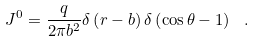Convert formula to latex. <formula><loc_0><loc_0><loc_500><loc_500>J ^ { 0 } = { \frac { q } { 2 \pi { b } ^ { 2 } } } \delta \left ( r - b \right ) \delta \left ( \cos \theta - 1 \right ) \ .</formula> 